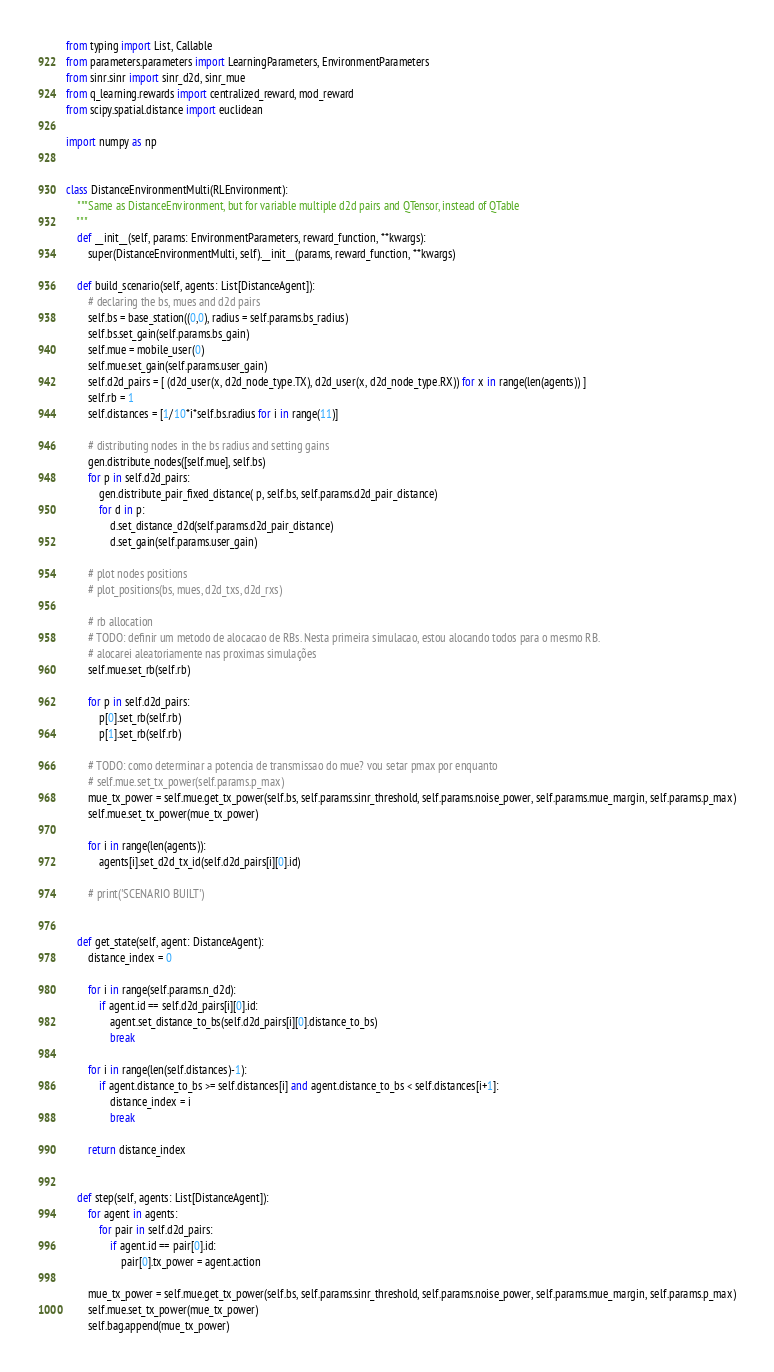<code> <loc_0><loc_0><loc_500><loc_500><_Python_>from typing import List, Callable
from parameters.parameters import LearningParameters, EnvironmentParameters
from sinr.sinr import sinr_d2d, sinr_mue
from q_learning.rewards import centralized_reward, mod_reward
from scipy.spatial.distance import euclidean

import numpy as np


class DistanceEnvironmentMulti(RLEnvironment):
    """Same as DistanceEnvironment, but for variable multiple d2d pairs and QTensor, instead of QTable
    """
    def __init__(self, params: EnvironmentParameters, reward_function, **kwargs):
        super(DistanceEnvironmentMulti, self).__init__(params, reward_function, **kwargs)

    def build_scenario(self, agents: List[DistanceAgent]):
        # declaring the bs, mues and d2d pairs
        self.bs = base_station((0,0), radius = self.params.bs_radius)
        self.bs.set_gain(self.params.bs_gain)
        self.mue = mobile_user(0)
        self.mue.set_gain(self.params.user_gain)
        self.d2d_pairs = [ (d2d_user(x, d2d_node_type.TX), d2d_user(x, d2d_node_type.RX)) for x in range(len(agents)) ]                
        self.rb = 1
        self.distances = [1/10*i*self.bs.radius for i in range(11)]

        # distributing nodes in the bs radius and setting gains
        gen.distribute_nodes([self.mue], self.bs)
        for p in self.d2d_pairs:
            gen.distribute_pair_fixed_distance( p, self.bs, self.params.d2d_pair_distance)
            for d in p:
                d.set_distance_d2d(self.params.d2d_pair_distance)
                d.set_gain(self.params.user_gain)

        # plot nodes positions
        # plot_positions(bs, mues, d2d_txs, d2d_rxs)

        # rb allocation
        # TODO: definir um metodo de alocacao de RBs. Nesta primeira simulacao, estou alocando todos para o mesmo RB. 
        # alocarei aleatoriamente nas proximas simulações
        self.mue.set_rb(self.rb)

        for p in self.d2d_pairs:
            p[0].set_rb(self.rb)
            p[1].set_rb(self.rb)

        # TODO: como determinar a potencia de transmissao do mue? vou setar pmax por enquanto
        # self.mue.set_tx_power(self.params.p_max)
        mue_tx_power = self.mue.get_tx_power(self.bs, self.params.sinr_threshold, self.params.noise_power, self.params.mue_margin, self.params.p_max)
        self.mue.set_tx_power(mue_tx_power)

        for i in range(len(agents)):
            agents[i].set_d2d_tx_id(self.d2d_pairs[i][0].id)

        # print('SCENARIO BUILT')


    def get_state(self, agent: DistanceAgent):
        distance_index = 0

        for i in range(self.params.n_d2d):
            if agent.id == self.d2d_pairs[i][0].id:
                agent.set_distance_to_bs(self.d2d_pairs[i][0].distance_to_bs)
                break

        for i in range(len(self.distances)-1):
            if agent.distance_to_bs >= self.distances[i] and agent.distance_to_bs < self.distances[i+1]:
                distance_index = i
                break

        return distance_index


    def step(self, agents: List[DistanceAgent]):
        for agent in agents:
            for pair in self.d2d_pairs:
                if agent.id == pair[0].id:
                    pair[0].tx_power = agent.action

        mue_tx_power = self.mue.get_tx_power(self.bs, self.params.sinr_threshold, self.params.noise_power, self.params.mue_margin, self.params.p_max)
        self.mue.set_tx_power(mue_tx_power)
        self.bag.append(mue_tx_power)</code> 